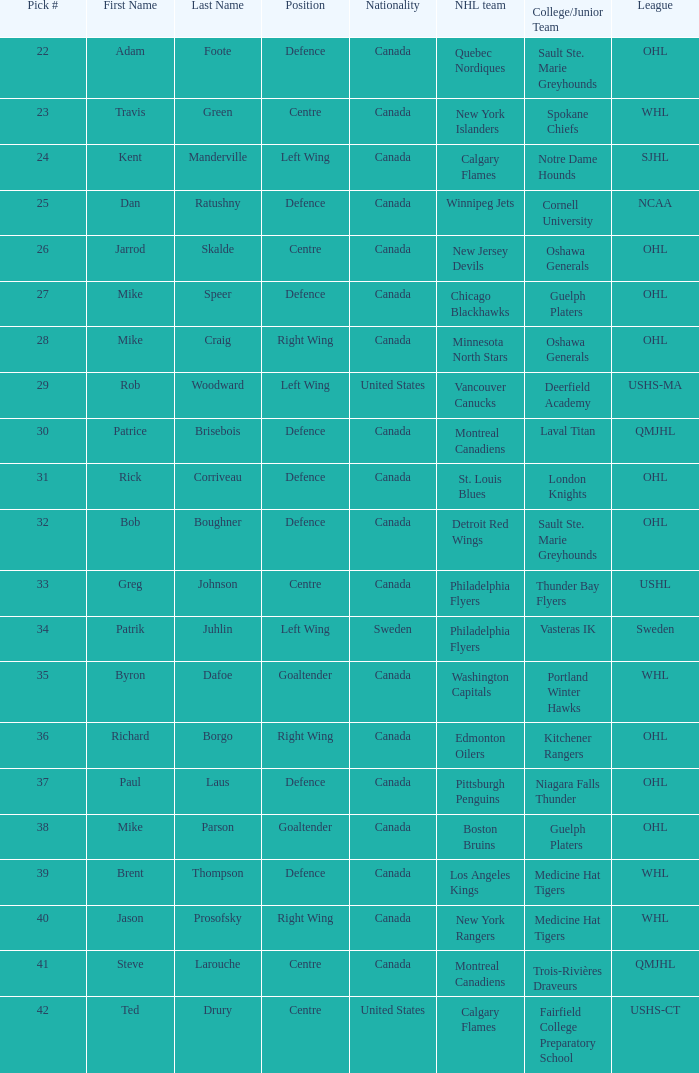What is the nationality of the player picked to go to Washington Capitals? Canada. 